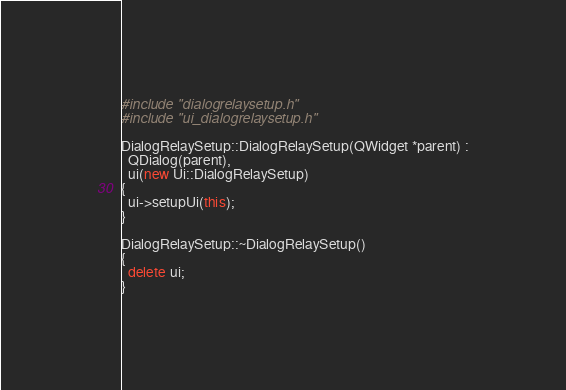<code> <loc_0><loc_0><loc_500><loc_500><_C++_>#include "dialogrelaysetup.h"
#include "ui_dialogrelaysetup.h"

DialogRelaySetup::DialogRelaySetup(QWidget *parent) :
  QDialog(parent),
  ui(new Ui::DialogRelaySetup)
{
  ui->setupUi(this);
}

DialogRelaySetup::~DialogRelaySetup()
{
  delete ui;
}
</code> 